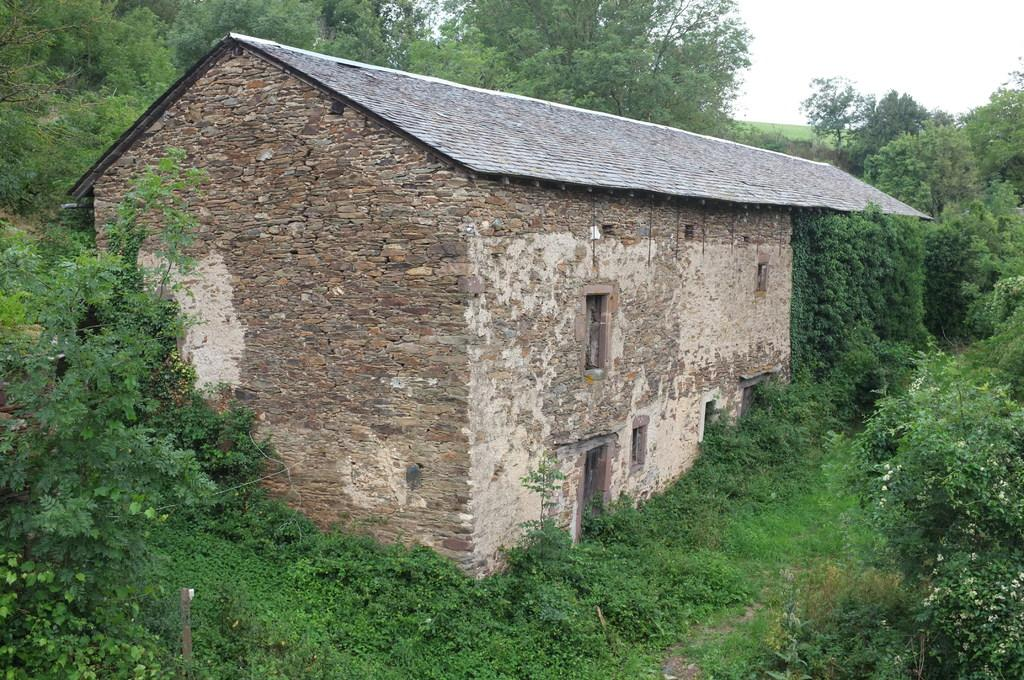What type of structure is present in the image? There is a house in the image. What other natural elements can be seen in the image? There are plants, trees, and the sky visible in the image. What part of the house allows for visibility and light? There are windows in the image. What type of acoustics can be heard from the ocean in the image? There is no ocean present in the image, so it is not possible to determine the acoustics. 